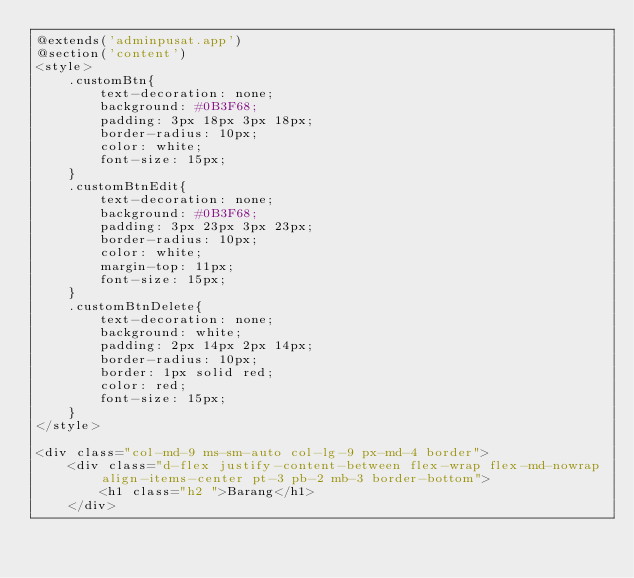Convert code to text. <code><loc_0><loc_0><loc_500><loc_500><_PHP_>@extends('adminpusat.app')
@section('content')
<style>
    .customBtn{
        text-decoration: none;
        background: #0B3F68;
        padding: 3px 18px 3px 18px;
        border-radius: 10px;
        color: white;
        font-size: 15px;
    }
    .customBtnEdit{
        text-decoration: none;
        background: #0B3F68;
        padding: 3px 23px 3px 23px;
        border-radius: 10px;
        color: white;
        margin-top: 11px;
        font-size: 15px;
    }
    .customBtnDelete{
        text-decoration: none;
        background: white;
        padding: 2px 14px 2px 14px;
        border-radius: 10px;
        border: 1px solid red;
        color: red;
        font-size: 15px;
    }
</style>

<div class="col-md-9 ms-sm-auto col-lg-9 px-md-4 border">
    <div class="d-flex justify-content-between flex-wrap flex-md-nowrap align-items-center pt-3 pb-2 mb-3 border-bottom">
        <h1 class="h2 ">Barang</h1>   
    </div></code> 